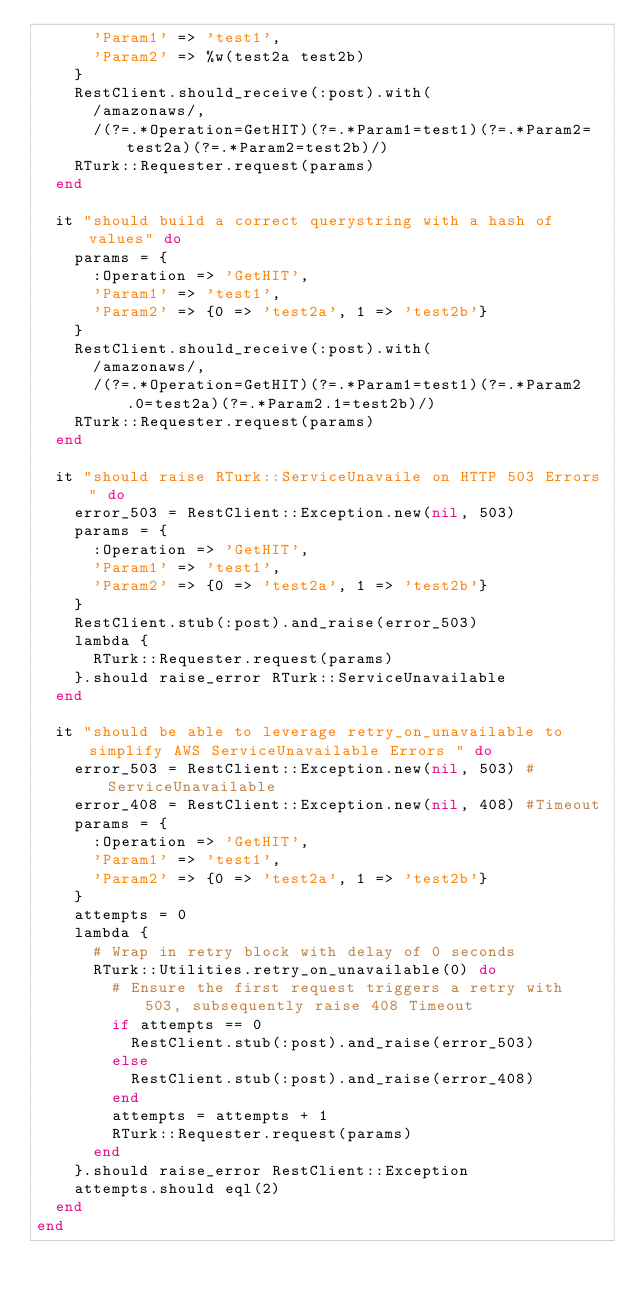<code> <loc_0><loc_0><loc_500><loc_500><_Ruby_>      'Param1' => 'test1',
      'Param2' => %w(test2a test2b)
    }
    RestClient.should_receive(:post).with(
      /amazonaws/,
      /(?=.*Operation=GetHIT)(?=.*Param1=test1)(?=.*Param2=test2a)(?=.*Param2=test2b)/)
    RTurk::Requester.request(params)
  end

  it "should build a correct querystring with a hash of values" do
    params = {
      :Operation => 'GetHIT',
      'Param1' => 'test1',
      'Param2' => {0 => 'test2a', 1 => 'test2b'}
    }
    RestClient.should_receive(:post).with(
      /amazonaws/,
      /(?=.*Operation=GetHIT)(?=.*Param1=test1)(?=.*Param2.0=test2a)(?=.*Param2.1=test2b)/)
    RTurk::Requester.request(params)
  end
  
  it "should raise RTurk::ServiceUnavaile on HTTP 503 Errors" do
    error_503 = RestClient::Exception.new(nil, 503)
    params = {
      :Operation => 'GetHIT',
      'Param1' => 'test1',
      'Param2' => {0 => 'test2a', 1 => 'test2b'}
    }
    RestClient.stub(:post).and_raise(error_503)
    lambda {
      RTurk::Requester.request(params)
    }.should raise_error RTurk::ServiceUnavailable
  end
  
  it "should be able to leverage retry_on_unavailable to simplify AWS ServiceUnavailable Errors " do
    error_503 = RestClient::Exception.new(nil, 503) #ServiceUnavailable
    error_408 = RestClient::Exception.new(nil, 408) #Timeout
    params = {
      :Operation => 'GetHIT',
      'Param1' => 'test1',
      'Param2' => {0 => 'test2a', 1 => 'test2b'}
    }
    attempts = 0
    lambda { 
      # Wrap in retry block with delay of 0 seconds
      RTurk::Utilities.retry_on_unavailable(0) do
        # Ensure the first request triggers a retry with 503, subsequently raise 408 Timeout
        if attempts == 0
          RestClient.stub(:post).and_raise(error_503)
        else
          RestClient.stub(:post).and_raise(error_408)
        end
        attempts = attempts + 1
        RTurk::Requester.request(params)
      end
    }.should raise_error RestClient::Exception
    attempts.should eql(2)
  end
end
</code> 